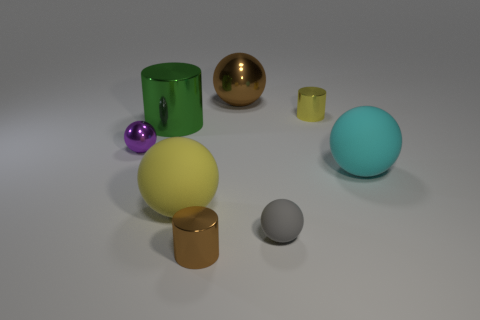Subtract all brown balls. How many balls are left? 4 Subtract all gray rubber balls. How many balls are left? 4 Subtract all red balls. Subtract all purple cubes. How many balls are left? 5 Add 1 small gray cylinders. How many objects exist? 9 Subtract all cylinders. How many objects are left? 5 Add 1 large spheres. How many large spheres are left? 4 Add 1 big blue metallic balls. How many big blue metallic balls exist? 1 Subtract 1 purple balls. How many objects are left? 7 Subtract all gray rubber objects. Subtract all yellow cylinders. How many objects are left? 6 